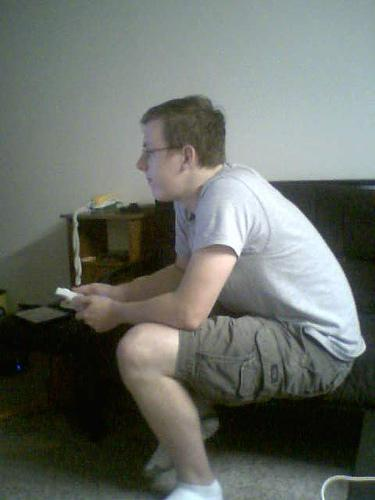Question: what is the man doing?
Choices:
A. Relaxing.
B. Sitting and watching.
C. Chilling.
D. Watching.
Answer with the letter. Answer: B Question: what is the color of the shirt?
Choices:
A. Grey.
B. Blue.
C. Dark.
D. White.
Answer with the letter. Answer: A Question: what is in the side table?
Choices:
A. Phone.
B. Plate.
C. Cup.
D. Keys.
Answer with the letter. Answer: A Question: what is the color of the bed?
Choices:
A. Blue.
B. Red.
C. Black.
D. White.
Answer with the letter. Answer: C Question: where is the picture taken?
Choices:
A. In the bathroom.
B. In the bedroom.
C. On the porch.
D. In the living room.
Answer with the letter. Answer: D Question: what is the color of the trouser?
Choices:
A. Blue.
B. Red.
C. Brown.
D. Black.
Answer with the letter. Answer: C 